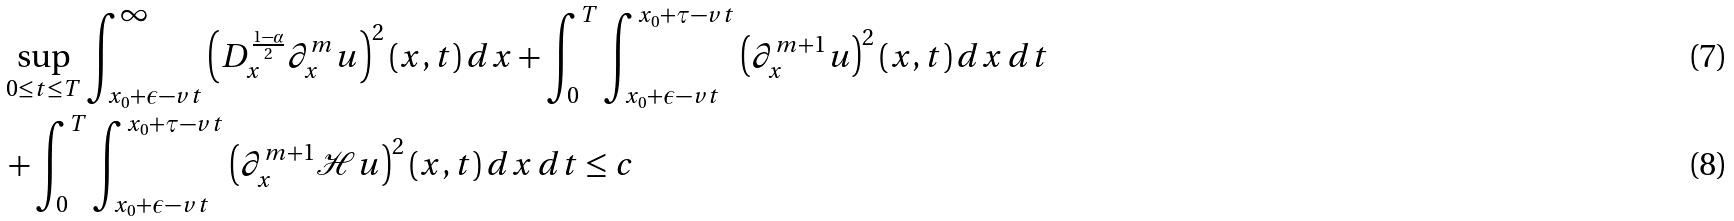<formula> <loc_0><loc_0><loc_500><loc_500>& \sup _ { 0 \leq t \leq T } \int _ { x _ { 0 } + \epsilon - v t } ^ { \infty } \left ( D _ { x } ^ { \frac { 1 - \alpha } { 2 } } \partial _ { x } ^ { m } u \right ) ^ { 2 } ( x , t ) \, d x + \int _ { 0 } ^ { T } \int _ { x _ { 0 } + \epsilon - v t } ^ { x _ { 0 } + \tau - v t } \left ( \partial _ { x } ^ { m + 1 } u \right ) ^ { 2 } ( x , t ) \, d x \, d t \\ & + \int _ { 0 } ^ { T } \int _ { x _ { 0 } + \epsilon - v t } ^ { x _ { 0 } + \tau - v t } \left ( \partial _ { x } ^ { m + 1 } \mathcal { H } u \right ) ^ { 2 } ( x , t ) \, d x \, d t \leq c</formula> 